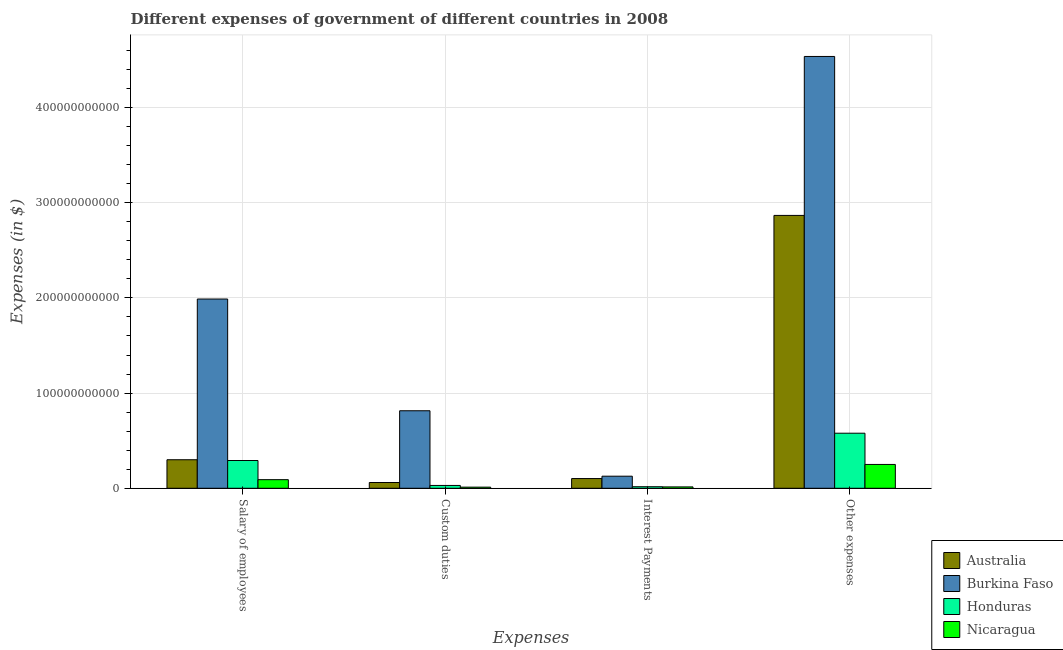Are the number of bars on each tick of the X-axis equal?
Offer a very short reply. Yes. How many bars are there on the 2nd tick from the left?
Your answer should be compact. 4. What is the label of the 1st group of bars from the left?
Your response must be concise. Salary of employees. What is the amount spent on other expenses in Nicaragua?
Make the answer very short. 2.50e+1. Across all countries, what is the maximum amount spent on custom duties?
Your response must be concise. 8.14e+1. Across all countries, what is the minimum amount spent on interest payments?
Your answer should be very brief. 1.45e+09. In which country was the amount spent on other expenses maximum?
Offer a very short reply. Burkina Faso. In which country was the amount spent on other expenses minimum?
Your response must be concise. Nicaragua. What is the total amount spent on salary of employees in the graph?
Provide a succinct answer. 2.67e+11. What is the difference between the amount spent on custom duties in Nicaragua and that in Honduras?
Ensure brevity in your answer.  -1.79e+09. What is the difference between the amount spent on custom duties in Nicaragua and the amount spent on other expenses in Burkina Faso?
Give a very brief answer. -4.52e+11. What is the average amount spent on other expenses per country?
Keep it short and to the point. 2.06e+11. What is the difference between the amount spent on salary of employees and amount spent on other expenses in Australia?
Make the answer very short. -2.57e+11. What is the ratio of the amount spent on other expenses in Burkina Faso to that in Australia?
Give a very brief answer. 1.58. What is the difference between the highest and the second highest amount spent on interest payments?
Your response must be concise. 2.48e+09. What is the difference between the highest and the lowest amount spent on custom duties?
Ensure brevity in your answer.  8.02e+1. Is the sum of the amount spent on interest payments in Honduras and Australia greater than the maximum amount spent on custom duties across all countries?
Provide a succinct answer. No. What does the 4th bar from the left in Interest Payments represents?
Offer a terse response. Nicaragua. What does the 3rd bar from the right in Custom duties represents?
Make the answer very short. Burkina Faso. Is it the case that in every country, the sum of the amount spent on salary of employees and amount spent on custom duties is greater than the amount spent on interest payments?
Make the answer very short. Yes. How many bars are there?
Make the answer very short. 16. Are all the bars in the graph horizontal?
Keep it short and to the point. No. What is the difference between two consecutive major ticks on the Y-axis?
Your answer should be very brief. 1.00e+11. How are the legend labels stacked?
Your answer should be compact. Vertical. What is the title of the graph?
Your answer should be very brief. Different expenses of government of different countries in 2008. What is the label or title of the X-axis?
Keep it short and to the point. Expenses. What is the label or title of the Y-axis?
Your answer should be compact. Expenses (in $). What is the Expenses (in $) of Australia in Salary of employees?
Ensure brevity in your answer.  3.00e+1. What is the Expenses (in $) in Burkina Faso in Salary of employees?
Your response must be concise. 1.99e+11. What is the Expenses (in $) in Honduras in Salary of employees?
Ensure brevity in your answer.  2.92e+1. What is the Expenses (in $) of Nicaragua in Salary of employees?
Keep it short and to the point. 9.05e+09. What is the Expenses (in $) in Australia in Custom duties?
Provide a short and direct response. 6.07e+09. What is the Expenses (in $) in Burkina Faso in Custom duties?
Your response must be concise. 8.14e+1. What is the Expenses (in $) of Honduras in Custom duties?
Provide a succinct answer. 2.98e+09. What is the Expenses (in $) of Nicaragua in Custom duties?
Provide a succinct answer. 1.18e+09. What is the Expenses (in $) of Australia in Interest Payments?
Ensure brevity in your answer.  1.02e+1. What is the Expenses (in $) of Burkina Faso in Interest Payments?
Your answer should be compact. 1.27e+1. What is the Expenses (in $) in Honduras in Interest Payments?
Your response must be concise. 1.63e+09. What is the Expenses (in $) in Nicaragua in Interest Payments?
Provide a short and direct response. 1.45e+09. What is the Expenses (in $) of Australia in Other expenses?
Keep it short and to the point. 2.87e+11. What is the Expenses (in $) in Burkina Faso in Other expenses?
Your answer should be compact. 4.54e+11. What is the Expenses (in $) of Honduras in Other expenses?
Your answer should be compact. 5.79e+1. What is the Expenses (in $) of Nicaragua in Other expenses?
Ensure brevity in your answer.  2.50e+1. Across all Expenses, what is the maximum Expenses (in $) of Australia?
Provide a succinct answer. 2.87e+11. Across all Expenses, what is the maximum Expenses (in $) of Burkina Faso?
Your answer should be very brief. 4.54e+11. Across all Expenses, what is the maximum Expenses (in $) in Honduras?
Provide a short and direct response. 5.79e+1. Across all Expenses, what is the maximum Expenses (in $) of Nicaragua?
Your answer should be very brief. 2.50e+1. Across all Expenses, what is the minimum Expenses (in $) in Australia?
Offer a very short reply. 6.07e+09. Across all Expenses, what is the minimum Expenses (in $) in Burkina Faso?
Provide a short and direct response. 1.27e+1. Across all Expenses, what is the minimum Expenses (in $) in Honduras?
Provide a short and direct response. 1.63e+09. Across all Expenses, what is the minimum Expenses (in $) of Nicaragua?
Keep it short and to the point. 1.18e+09. What is the total Expenses (in $) of Australia in the graph?
Your response must be concise. 3.33e+11. What is the total Expenses (in $) in Burkina Faso in the graph?
Provide a short and direct response. 7.47e+11. What is the total Expenses (in $) of Honduras in the graph?
Offer a terse response. 9.16e+1. What is the total Expenses (in $) of Nicaragua in the graph?
Your answer should be very brief. 3.67e+1. What is the difference between the Expenses (in $) of Australia in Salary of employees and that in Custom duties?
Give a very brief answer. 2.39e+1. What is the difference between the Expenses (in $) of Burkina Faso in Salary of employees and that in Custom duties?
Your response must be concise. 1.17e+11. What is the difference between the Expenses (in $) of Honduras in Salary of employees and that in Custom duties?
Make the answer very short. 2.62e+1. What is the difference between the Expenses (in $) of Nicaragua in Salary of employees and that in Custom duties?
Make the answer very short. 7.87e+09. What is the difference between the Expenses (in $) of Australia in Salary of employees and that in Interest Payments?
Your response must be concise. 1.98e+1. What is the difference between the Expenses (in $) in Burkina Faso in Salary of employees and that in Interest Payments?
Give a very brief answer. 1.86e+11. What is the difference between the Expenses (in $) of Honduras in Salary of employees and that in Interest Payments?
Your response must be concise. 2.76e+1. What is the difference between the Expenses (in $) of Nicaragua in Salary of employees and that in Interest Payments?
Ensure brevity in your answer.  7.60e+09. What is the difference between the Expenses (in $) in Australia in Salary of employees and that in Other expenses?
Your response must be concise. -2.57e+11. What is the difference between the Expenses (in $) in Burkina Faso in Salary of employees and that in Other expenses?
Provide a succinct answer. -2.55e+11. What is the difference between the Expenses (in $) of Honduras in Salary of employees and that in Other expenses?
Offer a very short reply. -2.87e+1. What is the difference between the Expenses (in $) in Nicaragua in Salary of employees and that in Other expenses?
Offer a very short reply. -1.60e+1. What is the difference between the Expenses (in $) of Australia in Custom duties and that in Interest Payments?
Ensure brevity in your answer.  -4.14e+09. What is the difference between the Expenses (in $) of Burkina Faso in Custom duties and that in Interest Payments?
Your response must be concise. 6.87e+1. What is the difference between the Expenses (in $) in Honduras in Custom duties and that in Interest Payments?
Ensure brevity in your answer.  1.35e+09. What is the difference between the Expenses (in $) of Nicaragua in Custom duties and that in Interest Payments?
Provide a short and direct response. -2.64e+08. What is the difference between the Expenses (in $) of Australia in Custom duties and that in Other expenses?
Your answer should be very brief. -2.81e+11. What is the difference between the Expenses (in $) in Burkina Faso in Custom duties and that in Other expenses?
Offer a very short reply. -3.72e+11. What is the difference between the Expenses (in $) in Honduras in Custom duties and that in Other expenses?
Your answer should be compact. -5.49e+1. What is the difference between the Expenses (in $) of Nicaragua in Custom duties and that in Other expenses?
Offer a very short reply. -2.38e+1. What is the difference between the Expenses (in $) of Australia in Interest Payments and that in Other expenses?
Offer a very short reply. -2.76e+11. What is the difference between the Expenses (in $) of Burkina Faso in Interest Payments and that in Other expenses?
Your response must be concise. -4.41e+11. What is the difference between the Expenses (in $) of Honduras in Interest Payments and that in Other expenses?
Your response must be concise. -5.62e+1. What is the difference between the Expenses (in $) of Nicaragua in Interest Payments and that in Other expenses?
Make the answer very short. -2.36e+1. What is the difference between the Expenses (in $) in Australia in Salary of employees and the Expenses (in $) in Burkina Faso in Custom duties?
Offer a very short reply. -5.14e+1. What is the difference between the Expenses (in $) in Australia in Salary of employees and the Expenses (in $) in Honduras in Custom duties?
Give a very brief answer. 2.70e+1. What is the difference between the Expenses (in $) in Australia in Salary of employees and the Expenses (in $) in Nicaragua in Custom duties?
Give a very brief answer. 2.88e+1. What is the difference between the Expenses (in $) in Burkina Faso in Salary of employees and the Expenses (in $) in Honduras in Custom duties?
Give a very brief answer. 1.96e+11. What is the difference between the Expenses (in $) of Burkina Faso in Salary of employees and the Expenses (in $) of Nicaragua in Custom duties?
Make the answer very short. 1.98e+11. What is the difference between the Expenses (in $) in Honduras in Salary of employees and the Expenses (in $) in Nicaragua in Custom duties?
Provide a short and direct response. 2.80e+1. What is the difference between the Expenses (in $) of Australia in Salary of employees and the Expenses (in $) of Burkina Faso in Interest Payments?
Your answer should be very brief. 1.73e+1. What is the difference between the Expenses (in $) of Australia in Salary of employees and the Expenses (in $) of Honduras in Interest Payments?
Keep it short and to the point. 2.84e+1. What is the difference between the Expenses (in $) of Australia in Salary of employees and the Expenses (in $) of Nicaragua in Interest Payments?
Provide a succinct answer. 2.85e+1. What is the difference between the Expenses (in $) of Burkina Faso in Salary of employees and the Expenses (in $) of Honduras in Interest Payments?
Your answer should be very brief. 1.97e+11. What is the difference between the Expenses (in $) of Burkina Faso in Salary of employees and the Expenses (in $) of Nicaragua in Interest Payments?
Provide a short and direct response. 1.97e+11. What is the difference between the Expenses (in $) in Honduras in Salary of employees and the Expenses (in $) in Nicaragua in Interest Payments?
Your answer should be very brief. 2.77e+1. What is the difference between the Expenses (in $) in Australia in Salary of employees and the Expenses (in $) in Burkina Faso in Other expenses?
Your response must be concise. -4.24e+11. What is the difference between the Expenses (in $) in Australia in Salary of employees and the Expenses (in $) in Honduras in Other expenses?
Give a very brief answer. -2.79e+1. What is the difference between the Expenses (in $) in Australia in Salary of employees and the Expenses (in $) in Nicaragua in Other expenses?
Keep it short and to the point. 4.95e+09. What is the difference between the Expenses (in $) in Burkina Faso in Salary of employees and the Expenses (in $) in Honduras in Other expenses?
Offer a terse response. 1.41e+11. What is the difference between the Expenses (in $) in Burkina Faso in Salary of employees and the Expenses (in $) in Nicaragua in Other expenses?
Keep it short and to the point. 1.74e+11. What is the difference between the Expenses (in $) of Honduras in Salary of employees and the Expenses (in $) of Nicaragua in Other expenses?
Your answer should be very brief. 4.15e+09. What is the difference between the Expenses (in $) of Australia in Custom duties and the Expenses (in $) of Burkina Faso in Interest Payments?
Give a very brief answer. -6.62e+09. What is the difference between the Expenses (in $) of Australia in Custom duties and the Expenses (in $) of Honduras in Interest Payments?
Keep it short and to the point. 4.44e+09. What is the difference between the Expenses (in $) of Australia in Custom duties and the Expenses (in $) of Nicaragua in Interest Payments?
Offer a terse response. 4.62e+09. What is the difference between the Expenses (in $) of Burkina Faso in Custom duties and the Expenses (in $) of Honduras in Interest Payments?
Offer a very short reply. 7.98e+1. What is the difference between the Expenses (in $) in Burkina Faso in Custom duties and the Expenses (in $) in Nicaragua in Interest Payments?
Keep it short and to the point. 8.00e+1. What is the difference between the Expenses (in $) in Honduras in Custom duties and the Expenses (in $) in Nicaragua in Interest Payments?
Provide a short and direct response. 1.53e+09. What is the difference between the Expenses (in $) in Australia in Custom duties and the Expenses (in $) in Burkina Faso in Other expenses?
Provide a succinct answer. -4.48e+11. What is the difference between the Expenses (in $) in Australia in Custom duties and the Expenses (in $) in Honduras in Other expenses?
Offer a very short reply. -5.18e+1. What is the difference between the Expenses (in $) in Australia in Custom duties and the Expenses (in $) in Nicaragua in Other expenses?
Your answer should be very brief. -1.90e+1. What is the difference between the Expenses (in $) of Burkina Faso in Custom duties and the Expenses (in $) of Honduras in Other expenses?
Give a very brief answer. 2.36e+1. What is the difference between the Expenses (in $) in Burkina Faso in Custom duties and the Expenses (in $) in Nicaragua in Other expenses?
Provide a short and direct response. 5.64e+1. What is the difference between the Expenses (in $) of Honduras in Custom duties and the Expenses (in $) of Nicaragua in Other expenses?
Keep it short and to the point. -2.21e+1. What is the difference between the Expenses (in $) in Australia in Interest Payments and the Expenses (in $) in Burkina Faso in Other expenses?
Keep it short and to the point. -4.43e+11. What is the difference between the Expenses (in $) in Australia in Interest Payments and the Expenses (in $) in Honduras in Other expenses?
Your answer should be compact. -4.76e+1. What is the difference between the Expenses (in $) in Australia in Interest Payments and the Expenses (in $) in Nicaragua in Other expenses?
Your answer should be compact. -1.48e+1. What is the difference between the Expenses (in $) of Burkina Faso in Interest Payments and the Expenses (in $) of Honduras in Other expenses?
Make the answer very short. -4.52e+1. What is the difference between the Expenses (in $) in Burkina Faso in Interest Payments and the Expenses (in $) in Nicaragua in Other expenses?
Provide a succinct answer. -1.23e+1. What is the difference between the Expenses (in $) in Honduras in Interest Payments and the Expenses (in $) in Nicaragua in Other expenses?
Your answer should be compact. -2.34e+1. What is the average Expenses (in $) of Australia per Expenses?
Give a very brief answer. 8.32e+1. What is the average Expenses (in $) of Burkina Faso per Expenses?
Offer a terse response. 1.87e+11. What is the average Expenses (in $) of Honduras per Expenses?
Give a very brief answer. 2.29e+1. What is the average Expenses (in $) of Nicaragua per Expenses?
Provide a succinct answer. 9.18e+09. What is the difference between the Expenses (in $) of Australia and Expenses (in $) of Burkina Faso in Salary of employees?
Offer a very short reply. -1.69e+11. What is the difference between the Expenses (in $) in Australia and Expenses (in $) in Honduras in Salary of employees?
Ensure brevity in your answer.  8.03e+08. What is the difference between the Expenses (in $) in Australia and Expenses (in $) in Nicaragua in Salary of employees?
Keep it short and to the point. 2.09e+1. What is the difference between the Expenses (in $) of Burkina Faso and Expenses (in $) of Honduras in Salary of employees?
Make the answer very short. 1.70e+11. What is the difference between the Expenses (in $) in Burkina Faso and Expenses (in $) in Nicaragua in Salary of employees?
Provide a succinct answer. 1.90e+11. What is the difference between the Expenses (in $) of Honduras and Expenses (in $) of Nicaragua in Salary of employees?
Your answer should be compact. 2.01e+1. What is the difference between the Expenses (in $) of Australia and Expenses (in $) of Burkina Faso in Custom duties?
Your answer should be compact. -7.54e+1. What is the difference between the Expenses (in $) in Australia and Expenses (in $) in Honduras in Custom duties?
Ensure brevity in your answer.  3.09e+09. What is the difference between the Expenses (in $) of Australia and Expenses (in $) of Nicaragua in Custom duties?
Your answer should be very brief. 4.89e+09. What is the difference between the Expenses (in $) in Burkina Faso and Expenses (in $) in Honduras in Custom duties?
Offer a terse response. 7.85e+1. What is the difference between the Expenses (in $) in Burkina Faso and Expenses (in $) in Nicaragua in Custom duties?
Your response must be concise. 8.02e+1. What is the difference between the Expenses (in $) of Honduras and Expenses (in $) of Nicaragua in Custom duties?
Provide a short and direct response. 1.79e+09. What is the difference between the Expenses (in $) of Australia and Expenses (in $) of Burkina Faso in Interest Payments?
Give a very brief answer. -2.48e+09. What is the difference between the Expenses (in $) of Australia and Expenses (in $) of Honduras in Interest Payments?
Provide a short and direct response. 8.58e+09. What is the difference between the Expenses (in $) in Australia and Expenses (in $) in Nicaragua in Interest Payments?
Ensure brevity in your answer.  8.76e+09. What is the difference between the Expenses (in $) of Burkina Faso and Expenses (in $) of Honduras in Interest Payments?
Keep it short and to the point. 1.11e+1. What is the difference between the Expenses (in $) of Burkina Faso and Expenses (in $) of Nicaragua in Interest Payments?
Your response must be concise. 1.12e+1. What is the difference between the Expenses (in $) in Honduras and Expenses (in $) in Nicaragua in Interest Payments?
Ensure brevity in your answer.  1.78e+08. What is the difference between the Expenses (in $) in Australia and Expenses (in $) in Burkina Faso in Other expenses?
Your answer should be compact. -1.67e+11. What is the difference between the Expenses (in $) in Australia and Expenses (in $) in Honduras in Other expenses?
Give a very brief answer. 2.29e+11. What is the difference between the Expenses (in $) in Australia and Expenses (in $) in Nicaragua in Other expenses?
Offer a very short reply. 2.62e+11. What is the difference between the Expenses (in $) of Burkina Faso and Expenses (in $) of Honduras in Other expenses?
Your response must be concise. 3.96e+11. What is the difference between the Expenses (in $) of Burkina Faso and Expenses (in $) of Nicaragua in Other expenses?
Your response must be concise. 4.29e+11. What is the difference between the Expenses (in $) of Honduras and Expenses (in $) of Nicaragua in Other expenses?
Ensure brevity in your answer.  3.28e+1. What is the ratio of the Expenses (in $) in Australia in Salary of employees to that in Custom duties?
Provide a succinct answer. 4.94. What is the ratio of the Expenses (in $) in Burkina Faso in Salary of employees to that in Custom duties?
Offer a very short reply. 2.44. What is the ratio of the Expenses (in $) of Honduras in Salary of employees to that in Custom duties?
Offer a terse response. 9.81. What is the ratio of the Expenses (in $) of Nicaragua in Salary of employees to that in Custom duties?
Make the answer very short. 7.65. What is the ratio of the Expenses (in $) of Australia in Salary of employees to that in Interest Payments?
Your answer should be compact. 2.94. What is the ratio of the Expenses (in $) of Burkina Faso in Salary of employees to that in Interest Payments?
Your answer should be very brief. 15.66. What is the ratio of the Expenses (in $) in Honduras in Salary of employees to that in Interest Payments?
Provide a short and direct response. 17.95. What is the ratio of the Expenses (in $) in Nicaragua in Salary of employees to that in Interest Payments?
Offer a terse response. 6.25. What is the ratio of the Expenses (in $) in Australia in Salary of employees to that in Other expenses?
Keep it short and to the point. 0.1. What is the ratio of the Expenses (in $) of Burkina Faso in Salary of employees to that in Other expenses?
Give a very brief answer. 0.44. What is the ratio of the Expenses (in $) of Honduras in Salary of employees to that in Other expenses?
Keep it short and to the point. 0.5. What is the ratio of the Expenses (in $) of Nicaragua in Salary of employees to that in Other expenses?
Make the answer very short. 0.36. What is the ratio of the Expenses (in $) of Australia in Custom duties to that in Interest Payments?
Your response must be concise. 0.59. What is the ratio of the Expenses (in $) of Burkina Faso in Custom duties to that in Interest Payments?
Your response must be concise. 6.42. What is the ratio of the Expenses (in $) in Honduras in Custom duties to that in Interest Payments?
Provide a succinct answer. 1.83. What is the ratio of the Expenses (in $) in Nicaragua in Custom duties to that in Interest Payments?
Provide a succinct answer. 0.82. What is the ratio of the Expenses (in $) of Australia in Custom duties to that in Other expenses?
Provide a short and direct response. 0.02. What is the ratio of the Expenses (in $) in Burkina Faso in Custom duties to that in Other expenses?
Ensure brevity in your answer.  0.18. What is the ratio of the Expenses (in $) in Honduras in Custom duties to that in Other expenses?
Your response must be concise. 0.05. What is the ratio of the Expenses (in $) of Nicaragua in Custom duties to that in Other expenses?
Ensure brevity in your answer.  0.05. What is the ratio of the Expenses (in $) in Australia in Interest Payments to that in Other expenses?
Your answer should be compact. 0.04. What is the ratio of the Expenses (in $) in Burkina Faso in Interest Payments to that in Other expenses?
Your answer should be very brief. 0.03. What is the ratio of the Expenses (in $) in Honduras in Interest Payments to that in Other expenses?
Provide a short and direct response. 0.03. What is the ratio of the Expenses (in $) of Nicaragua in Interest Payments to that in Other expenses?
Make the answer very short. 0.06. What is the difference between the highest and the second highest Expenses (in $) in Australia?
Ensure brevity in your answer.  2.57e+11. What is the difference between the highest and the second highest Expenses (in $) of Burkina Faso?
Make the answer very short. 2.55e+11. What is the difference between the highest and the second highest Expenses (in $) of Honduras?
Make the answer very short. 2.87e+1. What is the difference between the highest and the second highest Expenses (in $) in Nicaragua?
Provide a succinct answer. 1.60e+1. What is the difference between the highest and the lowest Expenses (in $) of Australia?
Offer a terse response. 2.81e+11. What is the difference between the highest and the lowest Expenses (in $) of Burkina Faso?
Provide a short and direct response. 4.41e+11. What is the difference between the highest and the lowest Expenses (in $) in Honduras?
Offer a terse response. 5.62e+1. What is the difference between the highest and the lowest Expenses (in $) in Nicaragua?
Your response must be concise. 2.38e+1. 